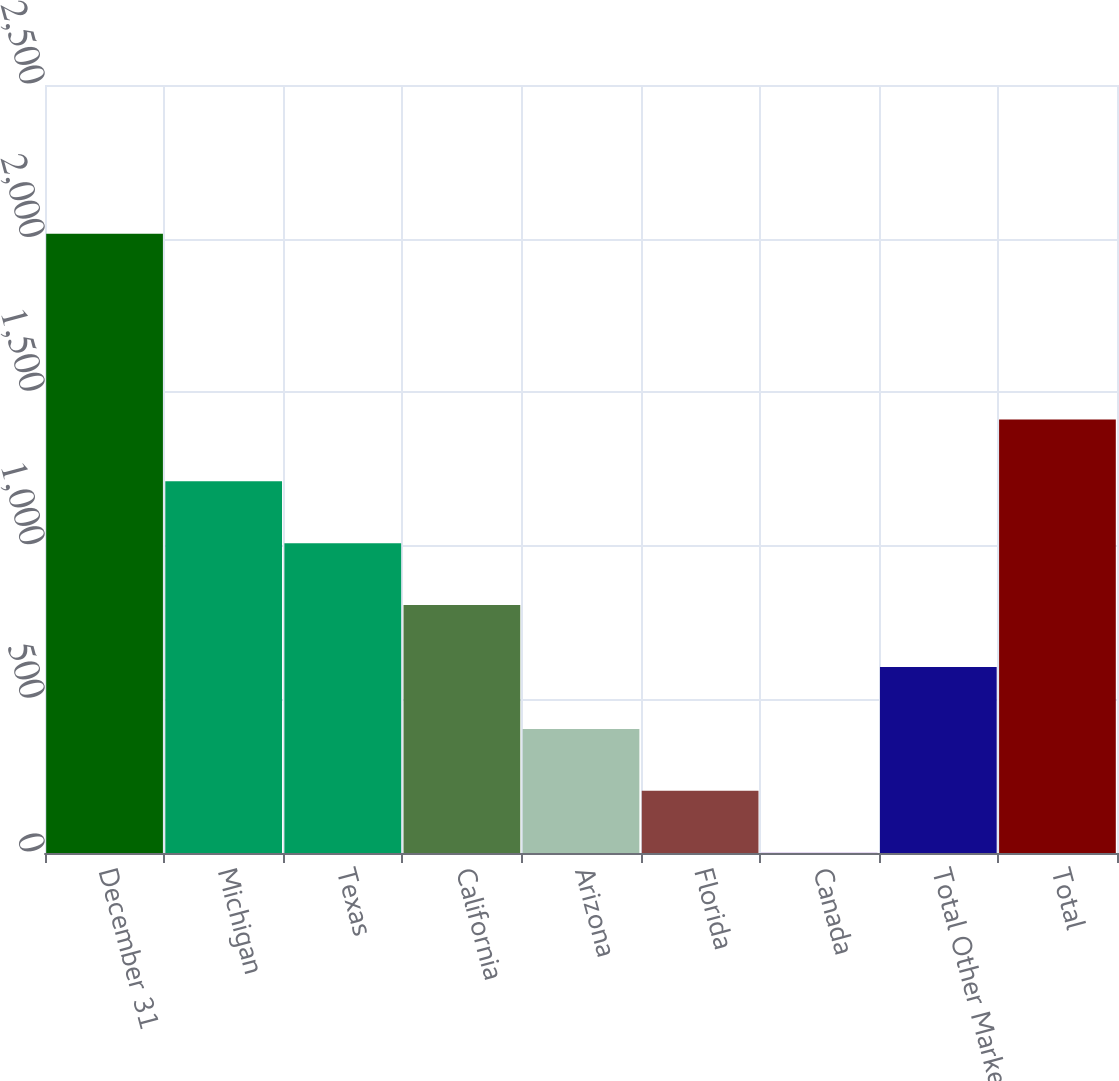<chart> <loc_0><loc_0><loc_500><loc_500><bar_chart><fcel>December 31<fcel>Michigan<fcel>Texas<fcel>California<fcel>Arizona<fcel>Florida<fcel>Canada<fcel>Total Other Markets<fcel>Total<nl><fcel>2016<fcel>1210<fcel>1008.5<fcel>807<fcel>404<fcel>202.5<fcel>1<fcel>605.5<fcel>1411.5<nl></chart> 